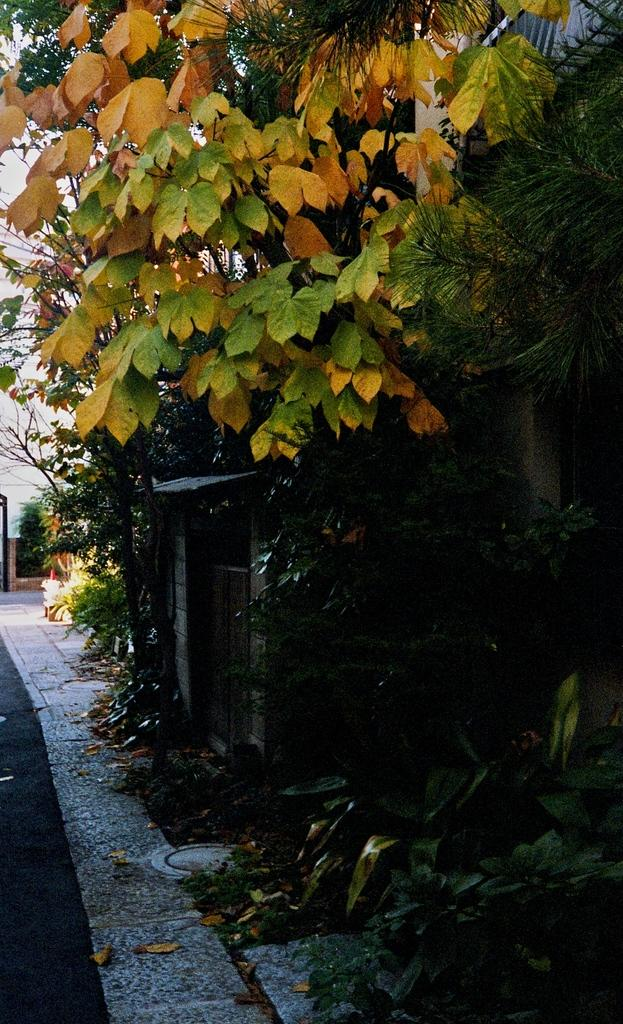What type of structures can be seen in the image? There are buildings in the image. What natural elements are present in the image? There are trees in the image. Can you describe the object in the image? Unfortunately, the facts provided do not give any details about the object in the image. What is at the bottom of the image? There is a road at the bottom of the image. How many sons does the wren in the image have? There is no wren present in the image, so it is not possible to determine how many sons it might have. 